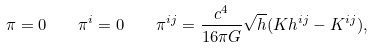Convert formula to latex. <formula><loc_0><loc_0><loc_500><loc_500>\pi = 0 \quad \pi ^ { i } = 0 \quad \pi ^ { i j } = \frac { c ^ { 4 } } { 1 6 \pi G } \sqrt { h } ( K h ^ { i j } - K ^ { i j } ) ,</formula> 